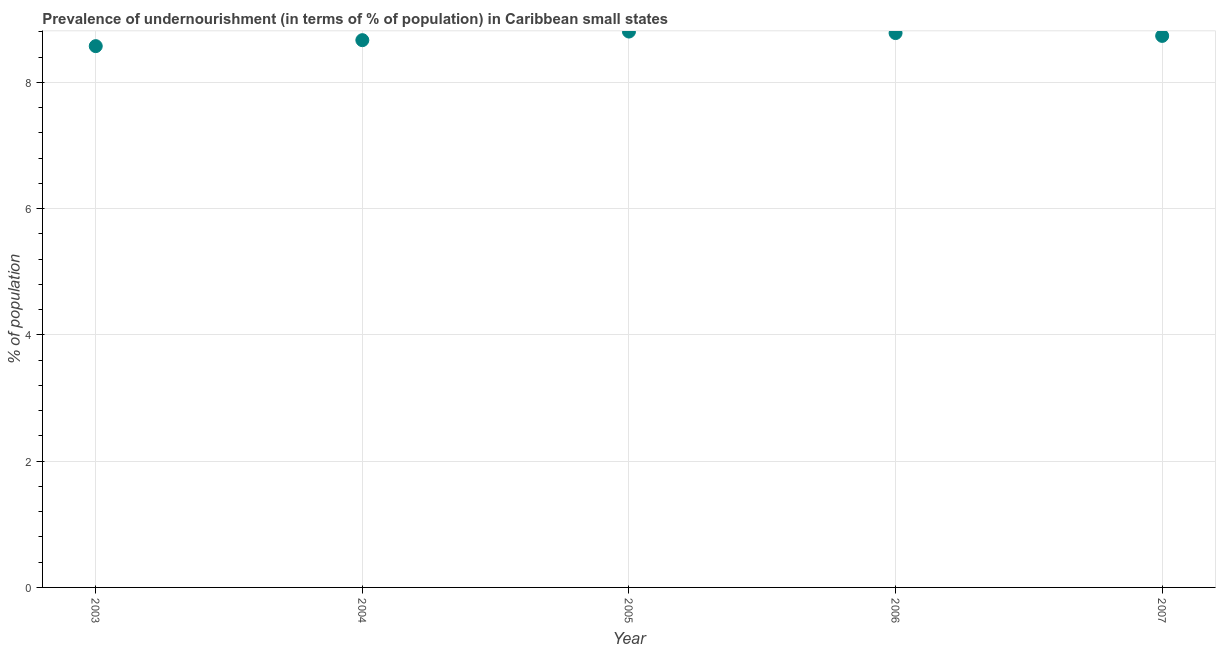What is the percentage of undernourished population in 2005?
Ensure brevity in your answer.  8.81. Across all years, what is the maximum percentage of undernourished population?
Provide a succinct answer. 8.81. Across all years, what is the minimum percentage of undernourished population?
Provide a short and direct response. 8.57. In which year was the percentage of undernourished population maximum?
Provide a short and direct response. 2005. What is the sum of the percentage of undernourished population?
Offer a terse response. 43.57. What is the difference between the percentage of undernourished population in 2003 and 2005?
Your answer should be very brief. -0.23. What is the average percentage of undernourished population per year?
Offer a terse response. 8.71. What is the median percentage of undernourished population?
Keep it short and to the point. 8.74. What is the ratio of the percentage of undernourished population in 2005 to that in 2006?
Your response must be concise. 1. Is the difference between the percentage of undernourished population in 2003 and 2004 greater than the difference between any two years?
Provide a short and direct response. No. What is the difference between the highest and the second highest percentage of undernourished population?
Make the answer very short. 0.02. Is the sum of the percentage of undernourished population in 2003 and 2006 greater than the maximum percentage of undernourished population across all years?
Your response must be concise. Yes. What is the difference between the highest and the lowest percentage of undernourished population?
Offer a terse response. 0.23. In how many years, is the percentage of undernourished population greater than the average percentage of undernourished population taken over all years?
Provide a succinct answer. 3. Does the percentage of undernourished population monotonically increase over the years?
Offer a very short reply. No. How many dotlines are there?
Your response must be concise. 1. How many years are there in the graph?
Offer a very short reply. 5. What is the difference between two consecutive major ticks on the Y-axis?
Your response must be concise. 2. Are the values on the major ticks of Y-axis written in scientific E-notation?
Your answer should be compact. No. Does the graph contain grids?
Offer a terse response. Yes. What is the title of the graph?
Offer a terse response. Prevalence of undernourishment (in terms of % of population) in Caribbean small states. What is the label or title of the Y-axis?
Keep it short and to the point. % of population. What is the % of population in 2003?
Ensure brevity in your answer.  8.57. What is the % of population in 2004?
Make the answer very short. 8.67. What is the % of population in 2005?
Give a very brief answer. 8.81. What is the % of population in 2006?
Give a very brief answer. 8.78. What is the % of population in 2007?
Make the answer very short. 8.74. What is the difference between the % of population in 2003 and 2004?
Give a very brief answer. -0.09. What is the difference between the % of population in 2003 and 2005?
Offer a very short reply. -0.23. What is the difference between the % of population in 2003 and 2006?
Give a very brief answer. -0.21. What is the difference between the % of population in 2003 and 2007?
Give a very brief answer. -0.16. What is the difference between the % of population in 2004 and 2005?
Give a very brief answer. -0.14. What is the difference between the % of population in 2004 and 2006?
Your answer should be compact. -0.11. What is the difference between the % of population in 2004 and 2007?
Give a very brief answer. -0.07. What is the difference between the % of population in 2005 and 2006?
Give a very brief answer. 0.02. What is the difference between the % of population in 2005 and 2007?
Your answer should be very brief. 0.07. What is the difference between the % of population in 2006 and 2007?
Give a very brief answer. 0.04. What is the ratio of the % of population in 2003 to that in 2004?
Your response must be concise. 0.99. What is the ratio of the % of population in 2003 to that in 2005?
Offer a very short reply. 0.97. What is the ratio of the % of population in 2003 to that in 2007?
Your answer should be compact. 0.98. What is the ratio of the % of population in 2005 to that in 2006?
Provide a succinct answer. 1. What is the ratio of the % of population in 2006 to that in 2007?
Ensure brevity in your answer.  1. 